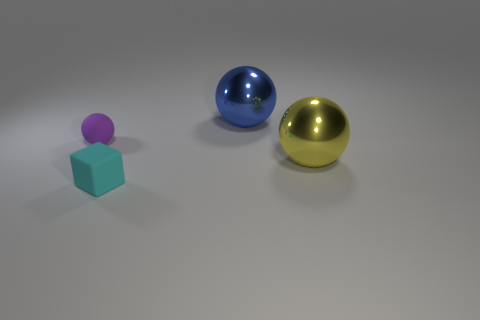What is the size of the shiny object behind the big metal ball in front of the tiny thing left of the tiny cyan cube?
Offer a terse response. Large. Does the tiny object that is left of the cyan rubber object have the same material as the yellow sphere?
Provide a succinct answer. No. Is the number of small cyan rubber things in front of the cyan rubber block the same as the number of purple rubber balls behind the big yellow metallic sphere?
Offer a very short reply. No. What material is the other small object that is the same shape as the blue object?
Make the answer very short. Rubber. There is a small rubber object in front of the small ball to the left of the blue metal sphere; is there a ball that is left of it?
Keep it short and to the point. Yes. There is a large shiny object in front of the large blue shiny sphere; does it have the same shape as the tiny matte thing behind the small cube?
Your response must be concise. Yes. Are there more big yellow objects behind the purple rubber object than big things?
Your response must be concise. No. What number of objects are large brown rubber spheres or tiny balls?
Offer a terse response. 1. The small matte ball has what color?
Ensure brevity in your answer.  Purple. Are there any metal balls to the left of the big yellow metallic sphere?
Ensure brevity in your answer.  Yes. 